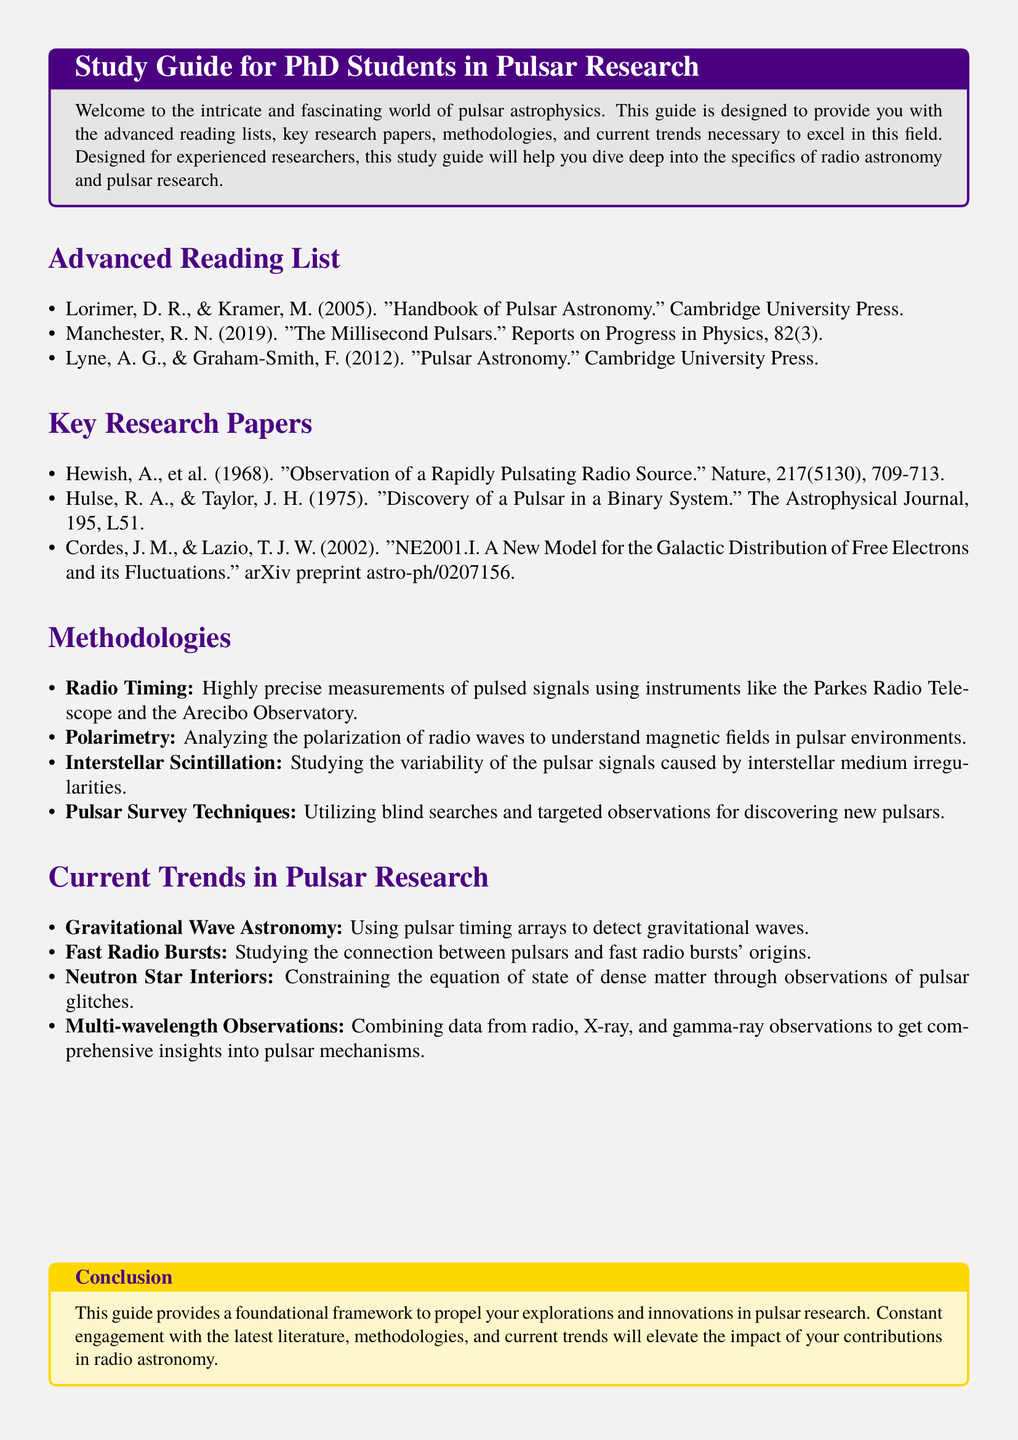What is the title of the guide? The title can be found at the beginning of the document, which states that it is a study guide for PhD students in pulsar research.
Answer: Study Guide for PhD Students in Pulsar Research Who are the authors of the "Handbook of Pulsar Astronomy"? The specific book title is listed in the advanced reading list along with its authors.
Answer: Lorimer, D. R., & Kramer, M What year was the paper "Observation of a Rapidly Pulsating Radio Source" published? The publication date is included in the key research papers section of the document.
Answer: 1968 What methodology utilizes the Parkes Radio Telescope? This methodology is listed and described in the methodologies section of the document.
Answer: Radio Timing Name one current trend in pulsar research. The list of current trends is found in the document, presenting several options.
Answer: Gravitational Wave Astronomy How many items are listed in the advanced reading list? The number of items can be counted directly in that section.
Answer: 3 Who discovered a pulsar in a binary system? The name of the researcher is found in the key research papers section of the document.
Answer: Hulse, R. A., & Taylor, J. H What is a technique used for discovering new pulsars? The methodologies section describes several techniques used in the field.
Answer: Pulsar Survey Techniques What color is used for the section titles? The document specifies the color used for section titles within its formatting.
Answer: Spacepurple 